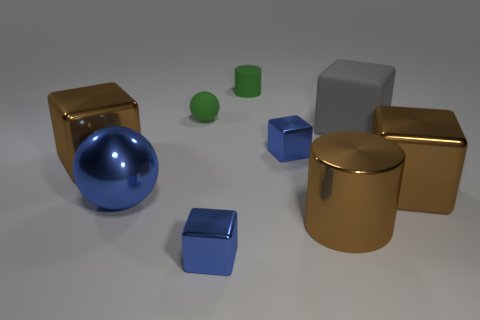Does the large block that is on the left side of the big blue object have the same color as the large shiny cylinder?
Your answer should be compact. Yes. What number of small blocks have the same color as the metal ball?
Ensure brevity in your answer.  2. What shape is the small object that is both in front of the tiny green cylinder and behind the large gray thing?
Offer a very short reply. Sphere. Does the tiny blue thing in front of the big blue sphere have the same shape as the brown metallic thing on the right side of the brown cylinder?
Provide a succinct answer. Yes. Are there any brown metallic blocks that have the same size as the green cylinder?
Your answer should be very brief. No. There is a cylinder that is in front of the large sphere; what is it made of?
Your answer should be compact. Metal. Does the blue object that is on the right side of the small rubber cylinder have the same material as the large blue ball?
Provide a succinct answer. Yes. Are there any gray metallic cylinders?
Your answer should be very brief. No. The cube that is made of the same material as the green sphere is what color?
Keep it short and to the point. Gray. There is a small cube left of the tiny cube behind the large cube on the left side of the large brown metallic cylinder; what is its color?
Your answer should be compact. Blue. 